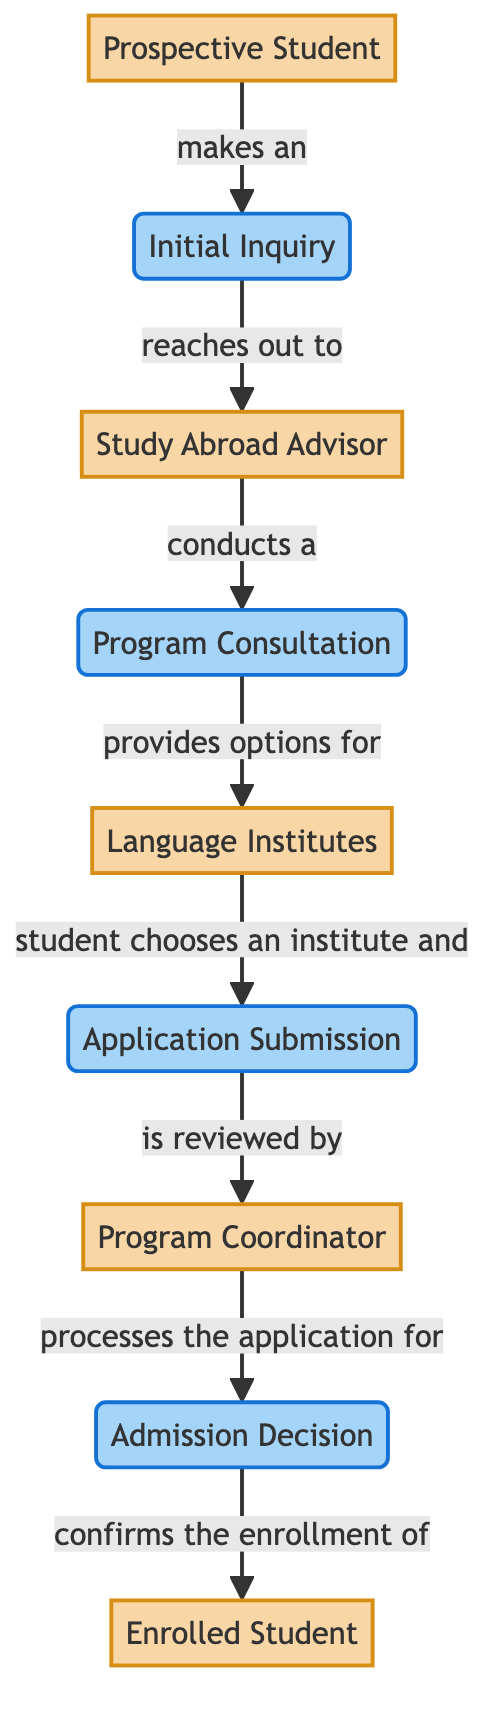What is the first step in the student enrollment flow? The diagram indicates that the first step in the student enrollment flow is the "Initial Inquiry" made by the "Prospective Student".
Answer: Initial Inquiry Who does the "Prospective Student" reach out to after making an inquiry? According to the diagram, after the "Prospective Student" makes an inquiry, they reach out to the "Study Abroad Advisor".
Answer: Study Abroad Advisor How many main entities are depicted in the diagram? The diagram shows five main entities, which are "Prospective Student", "Study Abroad Advisor", "Language Institutes", "Program Coordinator", and "Enrolled Student".
Answer: Five What process comes after the "Program Consultation"? The process that follows the "Program Consultation" is "Application Submission", where students apply to their chosen language institute.
Answer: Application Submission What happens during the "Admission Decision" stage? The "Admission Decision" stage is where the "Program Coordinator" reviews the application that was submitted by the student.
Answer: Application review Which entity is responsible for confirming the enrollment of the student? The "Enrolled Student" is confirmed by the "Admission Decision" process, which is processed by the "Program Coordinator".
Answer: Program Coordinator What is the relationship between "Language Institutes" and "Application Submission"? The relationship is that the "Language Institutes" are where the student selects a program and submits their application. Without choosing an institute, the application submission cannot happen.
Answer: Student chooses an institute and submits application How many processes are involved before a student is enrolled? There are four processes involved before a student is enrolled: "Initial Inquiry", "Program Consultation", "Application Submission", and "Admission Decision".
Answer: Four What is the output of the "Admission Decision" process? The output of the "Admission Decision" process is the confirmation of the enrollment of the student, leading to them becoming an "Enrolled Student".
Answer: Confirmation of enrollment 